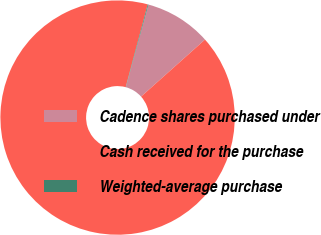Convert chart to OTSL. <chart><loc_0><loc_0><loc_500><loc_500><pie_chart><fcel>Cadence shares purchased under<fcel>Cash received for the purchase<fcel>Weighted-average purchase<nl><fcel>9.16%<fcel>90.73%<fcel>0.1%<nl></chart> 